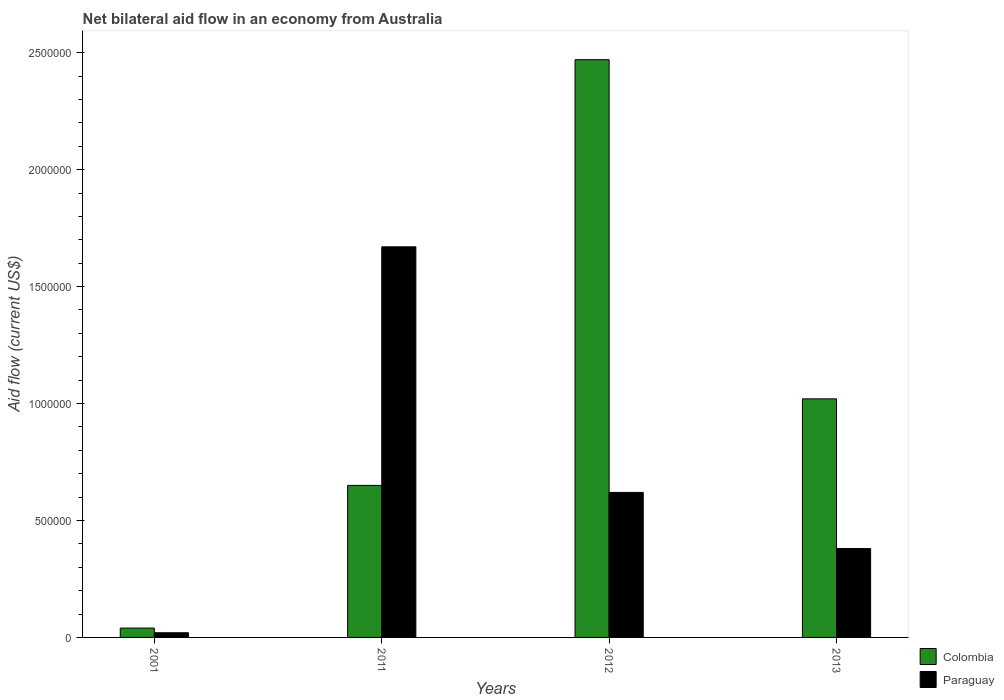How many different coloured bars are there?
Ensure brevity in your answer.  2. How many groups of bars are there?
Keep it short and to the point. 4. Are the number of bars per tick equal to the number of legend labels?
Make the answer very short. Yes. Are the number of bars on each tick of the X-axis equal?
Keep it short and to the point. Yes. What is the net bilateral aid flow in Paraguay in 2013?
Offer a very short reply. 3.80e+05. Across all years, what is the maximum net bilateral aid flow in Colombia?
Your answer should be very brief. 2.47e+06. What is the total net bilateral aid flow in Paraguay in the graph?
Ensure brevity in your answer.  2.69e+06. What is the difference between the net bilateral aid flow in Colombia in 2011 and that in 2012?
Make the answer very short. -1.82e+06. What is the difference between the net bilateral aid flow in Paraguay in 2011 and the net bilateral aid flow in Colombia in 2001?
Offer a very short reply. 1.63e+06. What is the average net bilateral aid flow in Paraguay per year?
Keep it short and to the point. 6.72e+05. In the year 2001, what is the difference between the net bilateral aid flow in Paraguay and net bilateral aid flow in Colombia?
Your answer should be compact. -2.00e+04. In how many years, is the net bilateral aid flow in Paraguay greater than 700000 US$?
Your answer should be compact. 1. What is the ratio of the net bilateral aid flow in Paraguay in 2001 to that in 2012?
Make the answer very short. 0.03. Is the net bilateral aid flow in Colombia in 2001 less than that in 2012?
Give a very brief answer. Yes. Is the difference between the net bilateral aid flow in Paraguay in 2001 and 2012 greater than the difference between the net bilateral aid flow in Colombia in 2001 and 2012?
Provide a short and direct response. Yes. What is the difference between the highest and the second highest net bilateral aid flow in Paraguay?
Provide a succinct answer. 1.05e+06. What is the difference between the highest and the lowest net bilateral aid flow in Colombia?
Make the answer very short. 2.43e+06. What does the 1st bar from the left in 2011 represents?
Make the answer very short. Colombia. What does the 1st bar from the right in 2013 represents?
Your answer should be compact. Paraguay. How many bars are there?
Offer a terse response. 8. Are the values on the major ticks of Y-axis written in scientific E-notation?
Make the answer very short. No. Does the graph contain any zero values?
Offer a terse response. No. Where does the legend appear in the graph?
Offer a very short reply. Bottom right. How many legend labels are there?
Ensure brevity in your answer.  2. How are the legend labels stacked?
Keep it short and to the point. Vertical. What is the title of the graph?
Provide a short and direct response. Net bilateral aid flow in an economy from Australia. What is the Aid flow (current US$) in Colombia in 2011?
Offer a very short reply. 6.50e+05. What is the Aid flow (current US$) in Paraguay in 2011?
Your answer should be very brief. 1.67e+06. What is the Aid flow (current US$) in Colombia in 2012?
Your response must be concise. 2.47e+06. What is the Aid flow (current US$) of Paraguay in 2012?
Offer a very short reply. 6.20e+05. What is the Aid flow (current US$) in Colombia in 2013?
Ensure brevity in your answer.  1.02e+06. Across all years, what is the maximum Aid flow (current US$) in Colombia?
Your answer should be very brief. 2.47e+06. Across all years, what is the maximum Aid flow (current US$) of Paraguay?
Keep it short and to the point. 1.67e+06. What is the total Aid flow (current US$) of Colombia in the graph?
Ensure brevity in your answer.  4.18e+06. What is the total Aid flow (current US$) of Paraguay in the graph?
Offer a terse response. 2.69e+06. What is the difference between the Aid flow (current US$) of Colombia in 2001 and that in 2011?
Give a very brief answer. -6.10e+05. What is the difference between the Aid flow (current US$) of Paraguay in 2001 and that in 2011?
Your answer should be very brief. -1.65e+06. What is the difference between the Aid flow (current US$) in Colombia in 2001 and that in 2012?
Your answer should be compact. -2.43e+06. What is the difference between the Aid flow (current US$) of Paraguay in 2001 and that in 2012?
Keep it short and to the point. -6.00e+05. What is the difference between the Aid flow (current US$) in Colombia in 2001 and that in 2013?
Your answer should be very brief. -9.80e+05. What is the difference between the Aid flow (current US$) of Paraguay in 2001 and that in 2013?
Ensure brevity in your answer.  -3.60e+05. What is the difference between the Aid flow (current US$) of Colombia in 2011 and that in 2012?
Provide a succinct answer. -1.82e+06. What is the difference between the Aid flow (current US$) of Paraguay in 2011 and that in 2012?
Offer a terse response. 1.05e+06. What is the difference between the Aid flow (current US$) in Colombia in 2011 and that in 2013?
Make the answer very short. -3.70e+05. What is the difference between the Aid flow (current US$) of Paraguay in 2011 and that in 2013?
Provide a short and direct response. 1.29e+06. What is the difference between the Aid flow (current US$) of Colombia in 2012 and that in 2013?
Give a very brief answer. 1.45e+06. What is the difference between the Aid flow (current US$) in Paraguay in 2012 and that in 2013?
Give a very brief answer. 2.40e+05. What is the difference between the Aid flow (current US$) of Colombia in 2001 and the Aid flow (current US$) of Paraguay in 2011?
Ensure brevity in your answer.  -1.63e+06. What is the difference between the Aid flow (current US$) in Colombia in 2001 and the Aid flow (current US$) in Paraguay in 2012?
Your answer should be very brief. -5.80e+05. What is the difference between the Aid flow (current US$) of Colombia in 2011 and the Aid flow (current US$) of Paraguay in 2013?
Provide a short and direct response. 2.70e+05. What is the difference between the Aid flow (current US$) in Colombia in 2012 and the Aid flow (current US$) in Paraguay in 2013?
Provide a short and direct response. 2.09e+06. What is the average Aid flow (current US$) of Colombia per year?
Offer a very short reply. 1.04e+06. What is the average Aid flow (current US$) in Paraguay per year?
Your response must be concise. 6.72e+05. In the year 2001, what is the difference between the Aid flow (current US$) in Colombia and Aid flow (current US$) in Paraguay?
Your answer should be compact. 2.00e+04. In the year 2011, what is the difference between the Aid flow (current US$) of Colombia and Aid flow (current US$) of Paraguay?
Offer a very short reply. -1.02e+06. In the year 2012, what is the difference between the Aid flow (current US$) in Colombia and Aid flow (current US$) in Paraguay?
Give a very brief answer. 1.85e+06. In the year 2013, what is the difference between the Aid flow (current US$) of Colombia and Aid flow (current US$) of Paraguay?
Your answer should be very brief. 6.40e+05. What is the ratio of the Aid flow (current US$) of Colombia in 2001 to that in 2011?
Provide a short and direct response. 0.06. What is the ratio of the Aid flow (current US$) of Paraguay in 2001 to that in 2011?
Provide a succinct answer. 0.01. What is the ratio of the Aid flow (current US$) of Colombia in 2001 to that in 2012?
Your answer should be compact. 0.02. What is the ratio of the Aid flow (current US$) of Paraguay in 2001 to that in 2012?
Offer a very short reply. 0.03. What is the ratio of the Aid flow (current US$) in Colombia in 2001 to that in 2013?
Provide a succinct answer. 0.04. What is the ratio of the Aid flow (current US$) in Paraguay in 2001 to that in 2013?
Your response must be concise. 0.05. What is the ratio of the Aid flow (current US$) in Colombia in 2011 to that in 2012?
Offer a very short reply. 0.26. What is the ratio of the Aid flow (current US$) in Paraguay in 2011 to that in 2012?
Your answer should be compact. 2.69. What is the ratio of the Aid flow (current US$) in Colombia in 2011 to that in 2013?
Provide a succinct answer. 0.64. What is the ratio of the Aid flow (current US$) in Paraguay in 2011 to that in 2013?
Keep it short and to the point. 4.39. What is the ratio of the Aid flow (current US$) of Colombia in 2012 to that in 2013?
Provide a succinct answer. 2.42. What is the ratio of the Aid flow (current US$) in Paraguay in 2012 to that in 2013?
Offer a very short reply. 1.63. What is the difference between the highest and the second highest Aid flow (current US$) of Colombia?
Your answer should be compact. 1.45e+06. What is the difference between the highest and the second highest Aid flow (current US$) in Paraguay?
Make the answer very short. 1.05e+06. What is the difference between the highest and the lowest Aid flow (current US$) of Colombia?
Provide a succinct answer. 2.43e+06. What is the difference between the highest and the lowest Aid flow (current US$) of Paraguay?
Provide a succinct answer. 1.65e+06. 